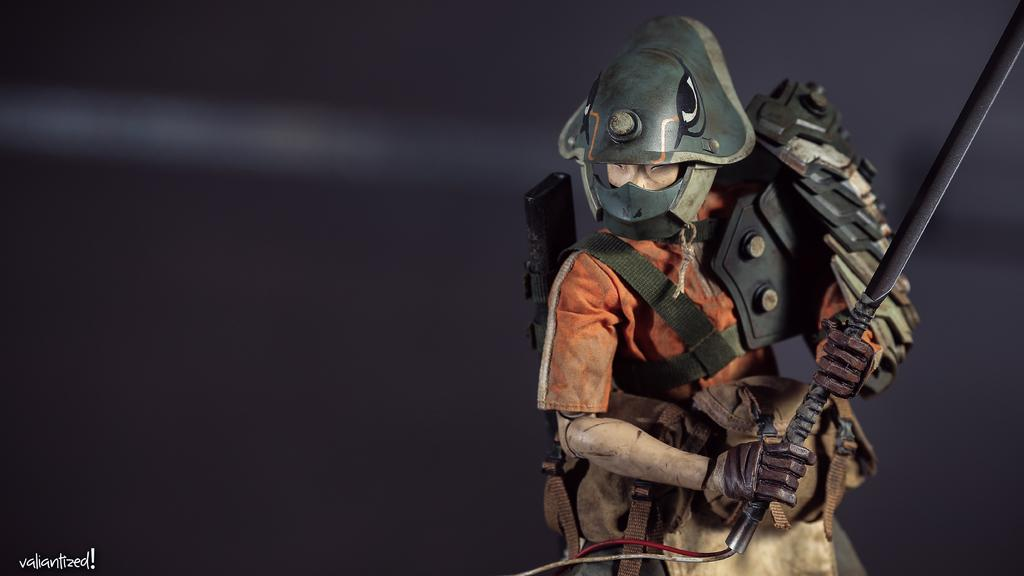What object can be seen in the image? There is a toy in the image. What is the toy holding? The toy is holding a sword. What type of protective gear is present in the image? There is a helmet in the image. What color is the toy's shirt? The toy is wearing an orange color shirt. What color is the background of the image? The background of the image is black. Where is the text located in the image? The text is on the left side of the image. What type of gold base can be seen supporting the toy in the image? There is no gold base present in the image; the toy is not shown resting on any base. 